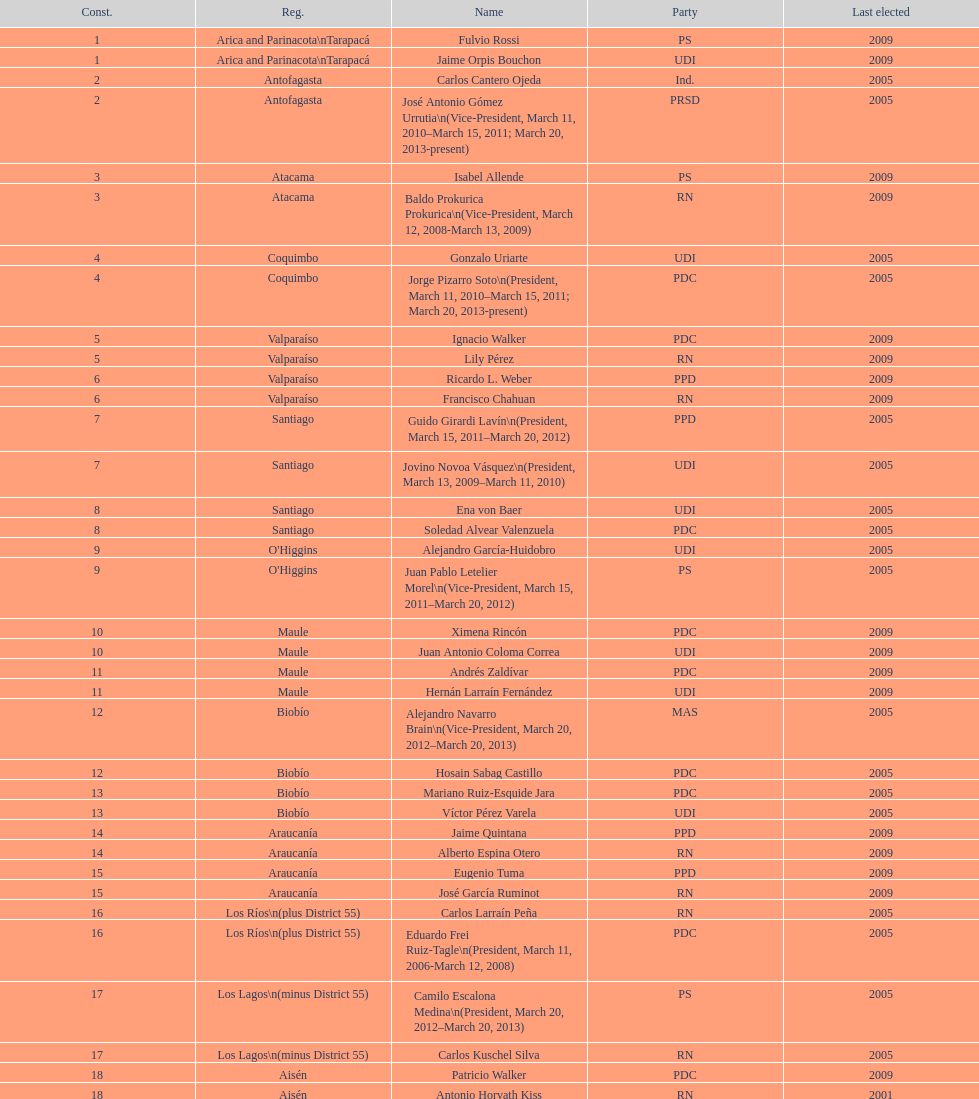What is the first name on the table? Fulvio Rossi. 